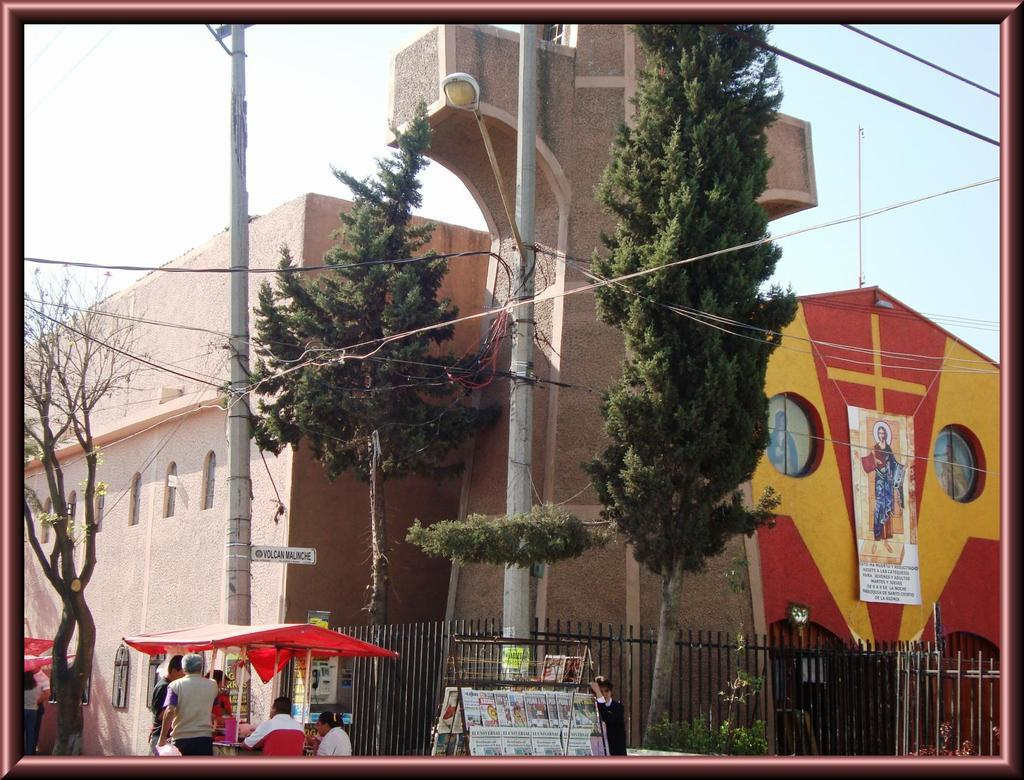What object is present in the image that contains images? There is a photo frame in the image that contains various images. What types of images can be seen in the photo frame? The photo frame contains images of the sky, a building, trees, a fence, power line cables, persons, and tents. What type of icicle can be seen hanging from the side of the photo frame? There is no icicle present in the image; it is a photo frame containing various images. Can you describe the body of the person in the photo frame? There is no specific person mentioned in the provided facts, and the image of persons is not detailed enough to describe a body. 